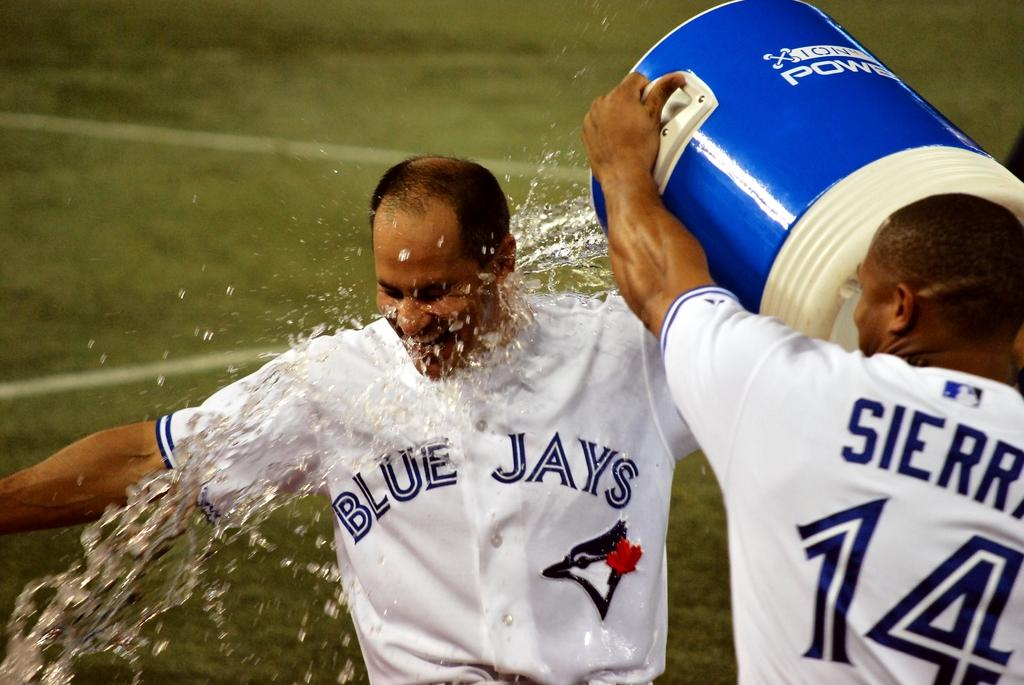<image>
Provide a brief description of the given image. Two baseball players in white and blue uniforms that says BLUE JAYS 